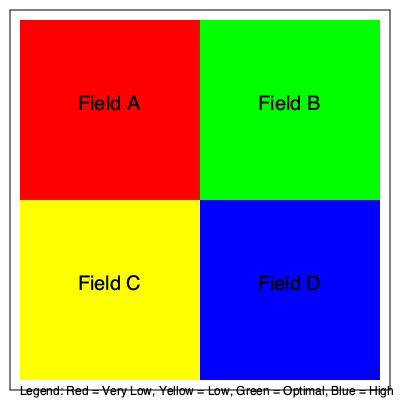Based on the color-coded map of soil phosphorus levels in your farm fields, which field requires the most urgent attention for phosphorus application, and what management strategy would you recommend to address the deficiency while considering environmental impact? To answer this question, we need to analyze the color-coded map and understand the implications of different phosphorus levels:

1. Interpret the color code:
   - Red = Very Low
   - Yellow = Low
   - Green = Optimal
   - Blue = High

2. Identify the phosphorus levels in each field:
   - Field A: Red (Very Low)
   - Field B: Green (Optimal)
   - Field C: Yellow (Low)
   - Field D: Blue (High)

3. Determine the field requiring most urgent attention:
   Field A has a very low phosphorus level, indicated by the red color. This field requires the most urgent attention as severe phosphorus deficiency can significantly impact crop yield and quality.

4. Consider management strategy:
   a) Soil testing: Conduct a detailed soil test to determine the exact phosphorus level and other nutrient deficiencies.
   
   b) Phosphorus application: Apply phosphorus fertilizer to bring the level up to optimal. The application rate should be calculated based on:
      - Soil test results
      - Crop requirements
      - Soil type and pH
   
   c) Application method: Consider using precision agriculture techniques such as variable-rate application to ensure uniform distribution and minimize over-application in some areas.
   
   d) Timing: Apply phosphorus when crops can best utilize it, typically before planting or during early growth stages.
   
   e) Environmental considerations:
      - Use slow-release phosphorus fertilizers to reduce runoff risk
      - Implement buffer strips near water bodies to prevent phosphorus loss
      - Practice crop rotation to improve nutrient cycling
   
   f) Monitor and adjust: Regularly test soil and plant tissue to track progress and adjust the fertilization strategy as needed.

5. Long-term strategy:
   Develop a nutrient management plan for all fields, paying attention to Field C (low phosphorus) and Field D (high phosphorus) to optimize overall farm nutrient balance and minimize environmental impact.
Answer: Field A; Apply phosphorus using precision agriculture techniques, considering soil test results, crop requirements, and environmental factors. 